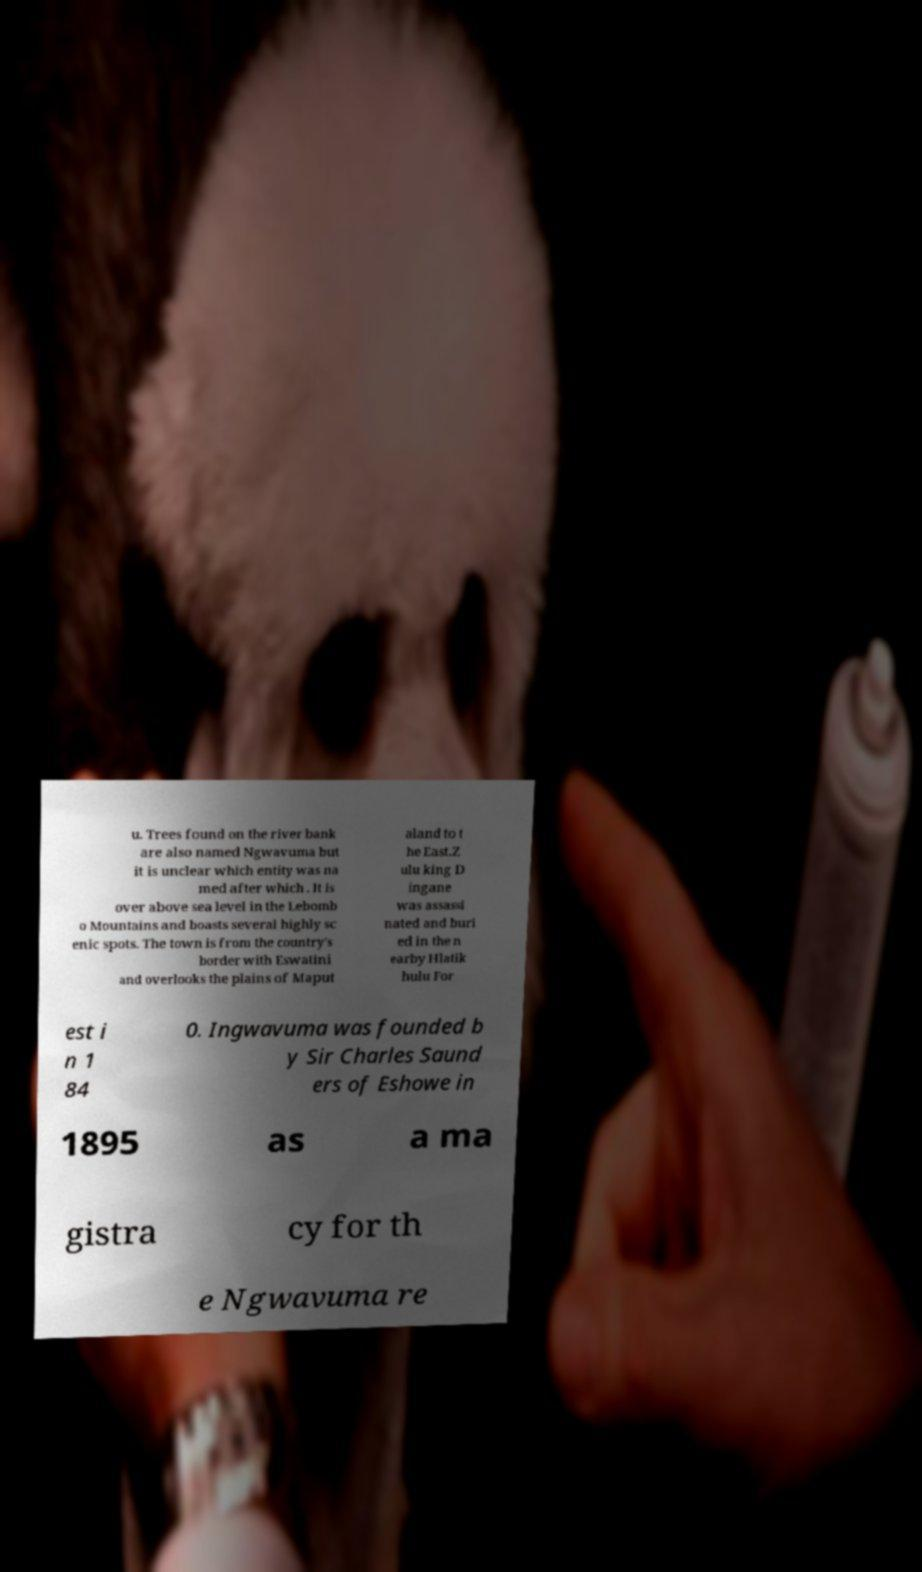Could you assist in decoding the text presented in this image and type it out clearly? u. Trees found on the river bank are also named Ngwavuma but it is unclear which entity was na med after which . It is over above sea level in the Lebomb o Mountains and boasts several highly sc enic spots. The town is from the country's border with Eswatini and overlooks the plains of Maput aland to t he East.Z ulu king D ingane was assassi nated and buri ed in the n earby Hlatik hulu For est i n 1 84 0. Ingwavuma was founded b y Sir Charles Saund ers of Eshowe in 1895 as a ma gistra cy for th e Ngwavuma re 